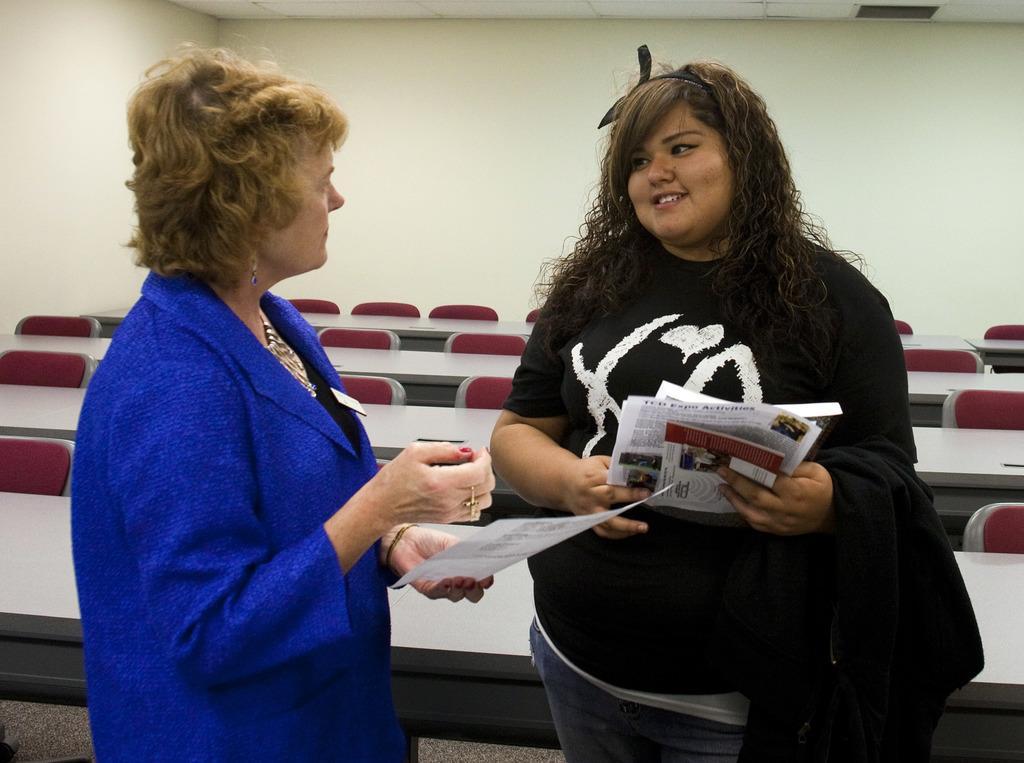Can you describe this image briefly? In this image there are two people standing by holding the papers. Behind them there are tables and chairs. At the back side there is a wall. 